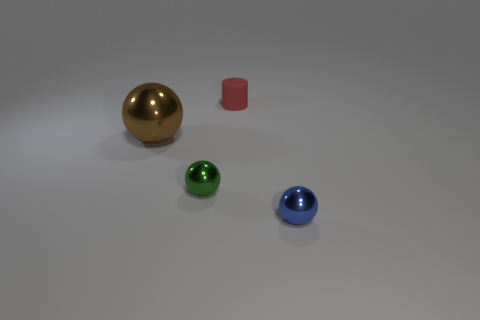Subtract all large balls. How many balls are left? 2 Add 1 big red objects. How many objects exist? 5 Subtract all gray spheres. Subtract all brown blocks. How many spheres are left? 3 Add 1 small red matte things. How many small red matte things are left? 2 Add 3 balls. How many balls exist? 6 Subtract 0 blue cubes. How many objects are left? 4 Subtract all spheres. How many objects are left? 1 Subtract all brown metallic things. Subtract all tiny spheres. How many objects are left? 1 